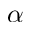Convert formula to latex. <formula><loc_0><loc_0><loc_500><loc_500>\alpha</formula> 